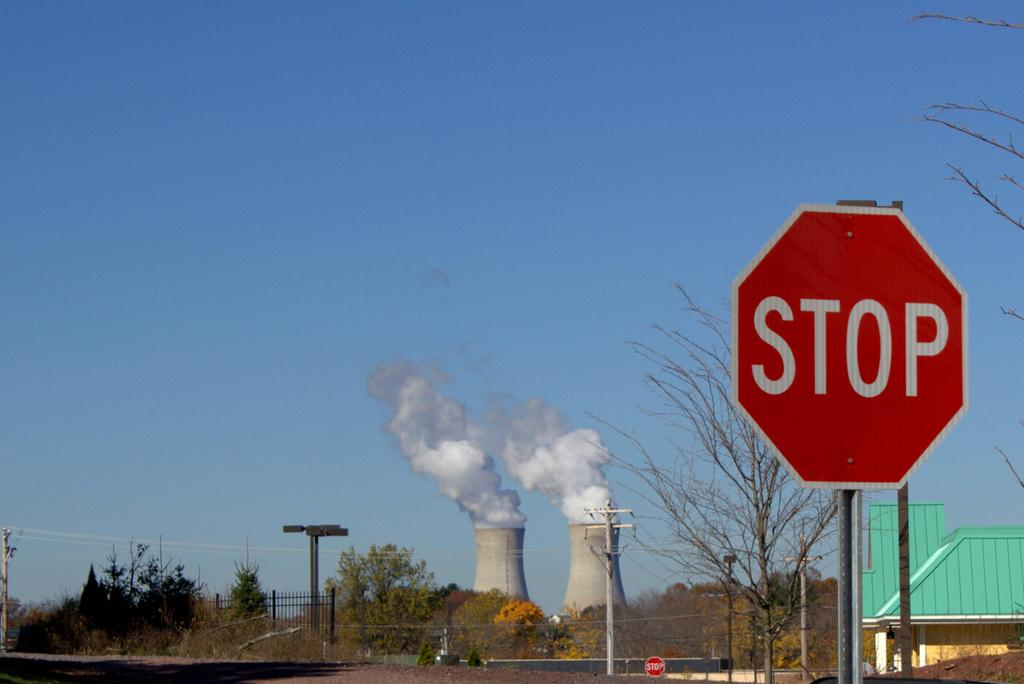<image>
Provide a brief description of the given image. A red sign that says Stop with two large smoke stacks in the background. 